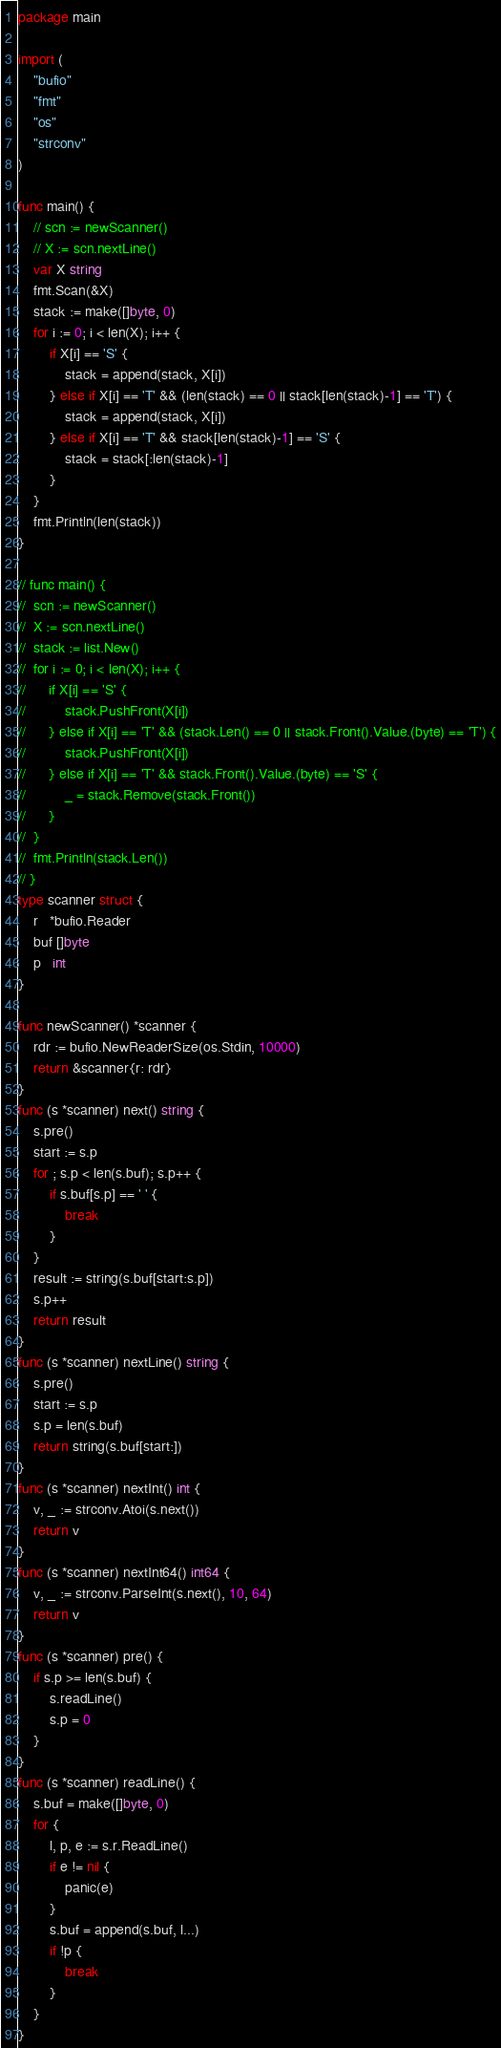Convert code to text. <code><loc_0><loc_0><loc_500><loc_500><_Go_>package main

import (
	"bufio"
	"fmt"
	"os"
	"strconv"
)

func main() {
	// scn := newScanner()
	// X := scn.nextLine()
	var X string
	fmt.Scan(&X)
	stack := make([]byte, 0)
	for i := 0; i < len(X); i++ {
		if X[i] == 'S' {
			stack = append(stack, X[i])
		} else if X[i] == 'T' && (len(stack) == 0 || stack[len(stack)-1] == 'T') {
			stack = append(stack, X[i])
		} else if X[i] == 'T' && stack[len(stack)-1] == 'S' {
			stack = stack[:len(stack)-1]
		}
	}
	fmt.Println(len(stack))
}

// func main() {
// 	scn := newScanner()
// 	X := scn.nextLine()
// 	stack := list.New()
// 	for i := 0; i < len(X); i++ {
// 		if X[i] == 'S' {
// 			stack.PushFront(X[i])
// 		} else if X[i] == 'T' && (stack.Len() == 0 || stack.Front().Value.(byte) == 'T') {
// 			stack.PushFront(X[i])
// 		} else if X[i] == 'T' && stack.Front().Value.(byte) == 'S' {
// 			_ = stack.Remove(stack.Front())
// 		}
// 	}
// 	fmt.Println(stack.Len())
// }
type scanner struct {
	r   *bufio.Reader
	buf []byte
	p   int
}

func newScanner() *scanner {
	rdr := bufio.NewReaderSize(os.Stdin, 10000)
	return &scanner{r: rdr}
}
func (s *scanner) next() string {
	s.pre()
	start := s.p
	for ; s.p < len(s.buf); s.p++ {
		if s.buf[s.p] == ' ' {
			break
		}
	}
	result := string(s.buf[start:s.p])
	s.p++
	return result
}
func (s *scanner) nextLine() string {
	s.pre()
	start := s.p
	s.p = len(s.buf)
	return string(s.buf[start:])
}
func (s *scanner) nextInt() int {
	v, _ := strconv.Atoi(s.next())
	return v
}
func (s *scanner) nextInt64() int64 {
	v, _ := strconv.ParseInt(s.next(), 10, 64)
	return v
}
func (s *scanner) pre() {
	if s.p >= len(s.buf) {
		s.readLine()
		s.p = 0
	}
}
func (s *scanner) readLine() {
	s.buf = make([]byte, 0)
	for {
		l, p, e := s.r.ReadLine()
		if e != nil {
			panic(e)
		}
		s.buf = append(s.buf, l...)
		if !p {
			break
		}
	}
}
</code> 